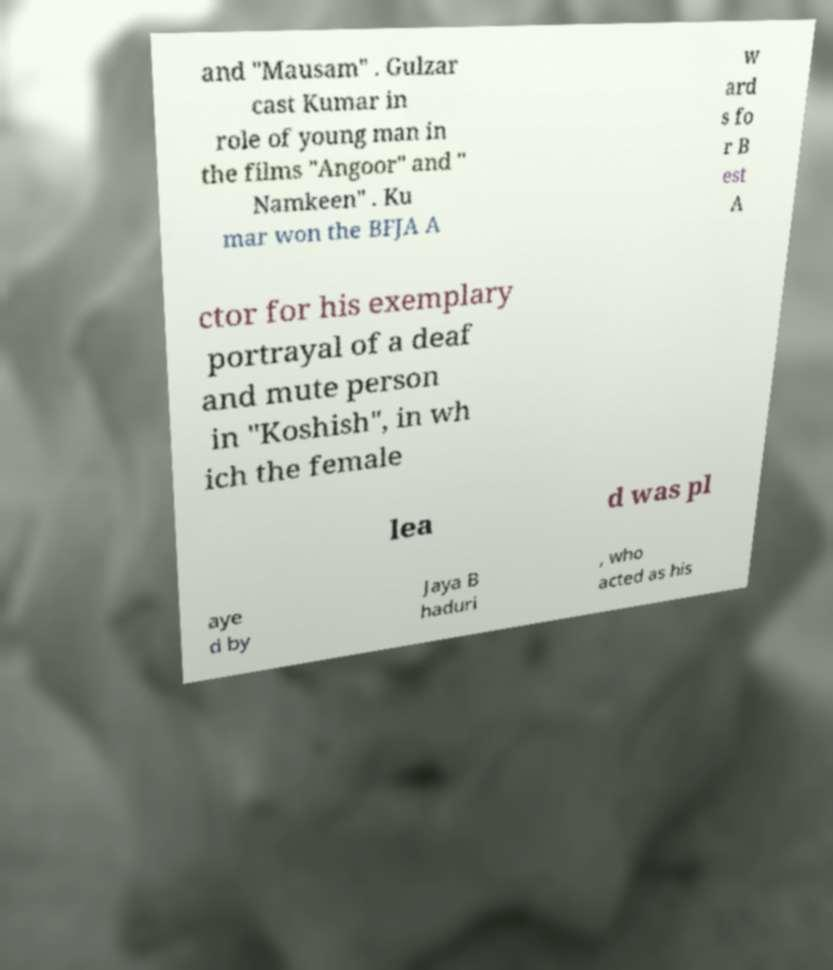Please read and relay the text visible in this image. What does it say? and "Mausam" . Gulzar cast Kumar in role of young man in the films "Angoor" and " Namkeen" . Ku mar won the BFJA A w ard s fo r B est A ctor for his exemplary portrayal of a deaf and mute person in "Koshish", in wh ich the female lea d was pl aye d by Jaya B haduri , who acted as his 